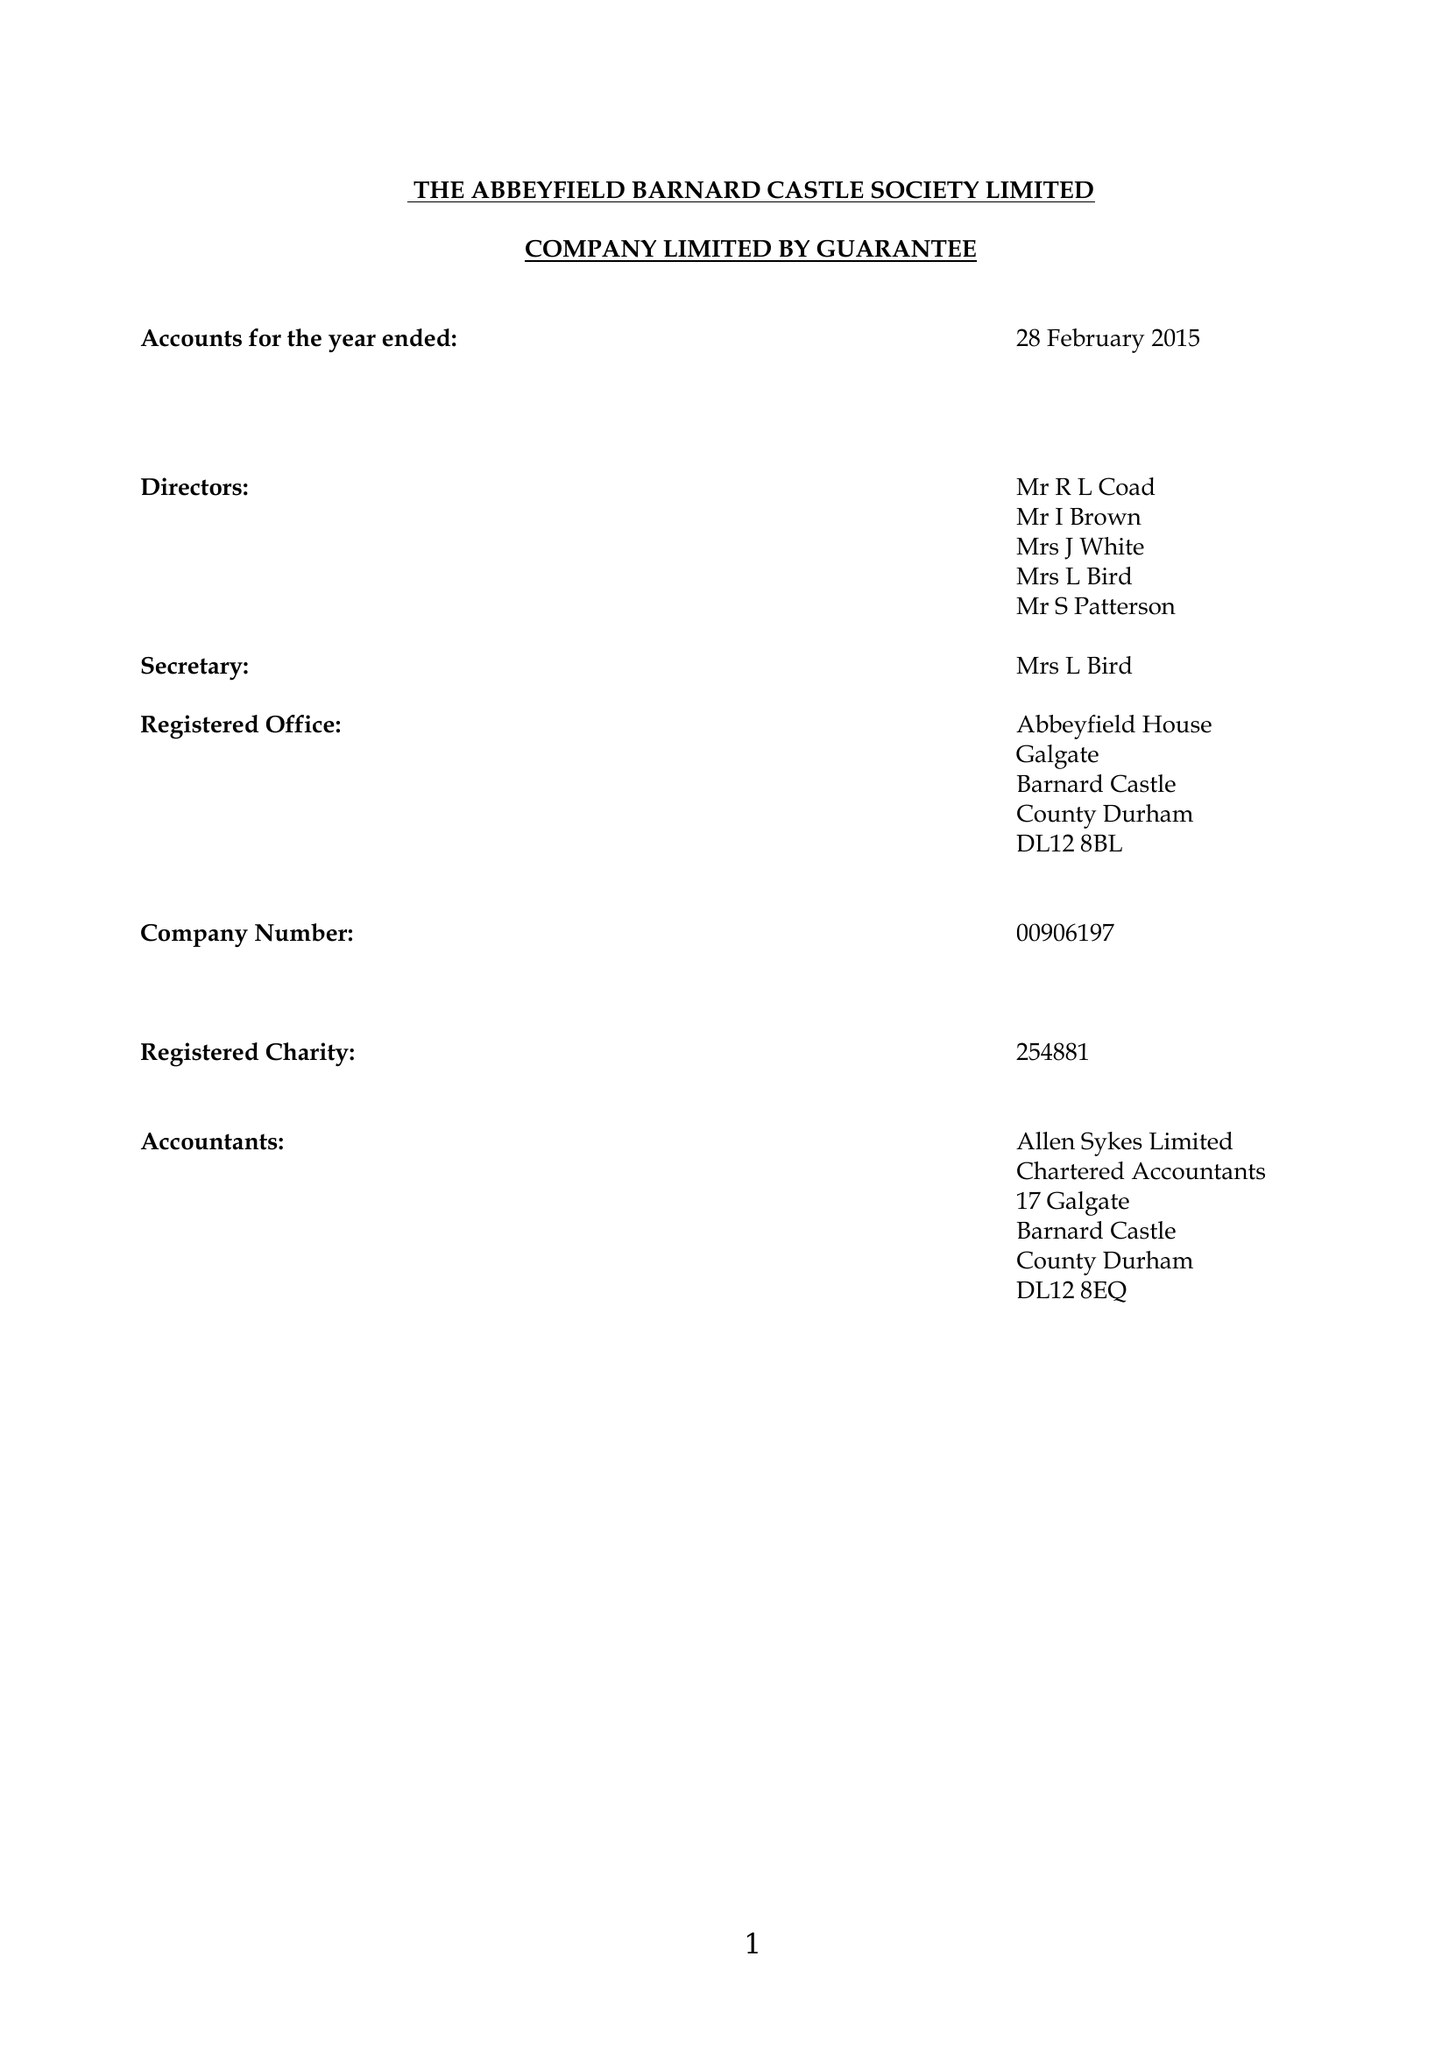What is the value for the address__street_line?
Answer the question using a single word or phrase. None 